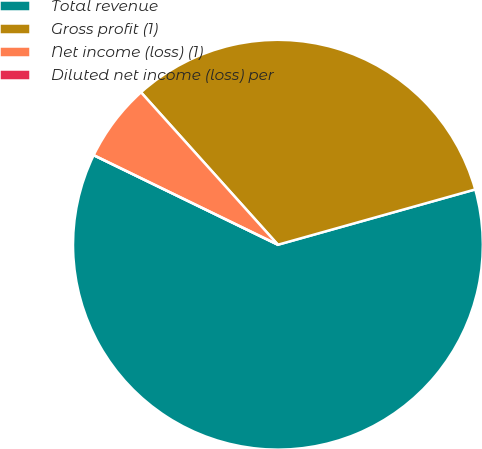Convert chart to OTSL. <chart><loc_0><loc_0><loc_500><loc_500><pie_chart><fcel>Total revenue<fcel>Gross profit (1)<fcel>Net income (loss) (1)<fcel>Diluted net income (loss) per<nl><fcel>61.55%<fcel>32.3%<fcel>6.15%<fcel>0.0%<nl></chart> 